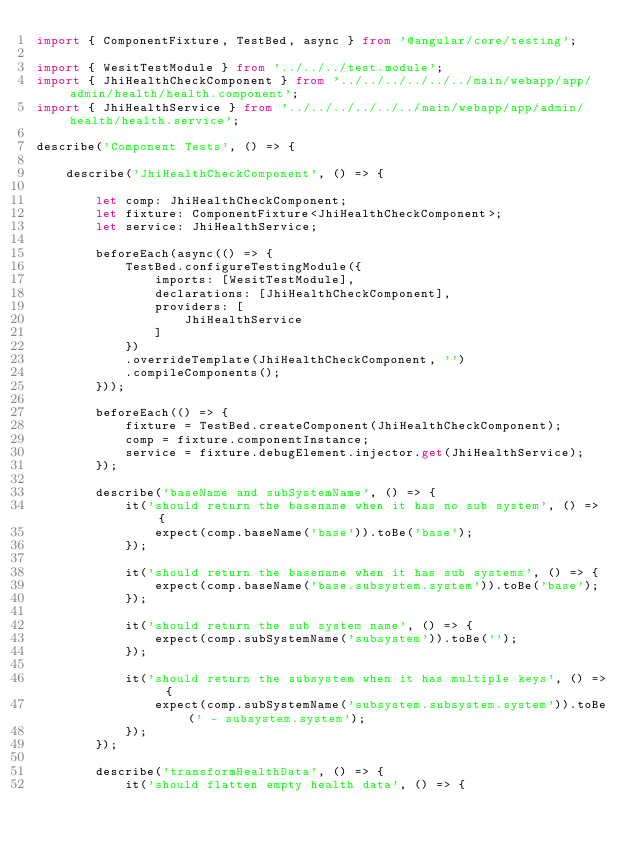Convert code to text. <code><loc_0><loc_0><loc_500><loc_500><_TypeScript_>import { ComponentFixture, TestBed, async } from '@angular/core/testing';

import { WesitTestModule } from '../../../test.module';
import { JhiHealthCheckComponent } from '../../../../../../main/webapp/app/admin/health/health.component';
import { JhiHealthService } from '../../../../../../main/webapp/app/admin/health/health.service';

describe('Component Tests', () => {

    describe('JhiHealthCheckComponent', () => {

        let comp: JhiHealthCheckComponent;
        let fixture: ComponentFixture<JhiHealthCheckComponent>;
        let service: JhiHealthService;

        beforeEach(async(() => {
            TestBed.configureTestingModule({
                imports: [WesitTestModule],
                declarations: [JhiHealthCheckComponent],
                providers: [
                    JhiHealthService
                ]
            })
            .overrideTemplate(JhiHealthCheckComponent, '')
            .compileComponents();
        }));

        beforeEach(() => {
            fixture = TestBed.createComponent(JhiHealthCheckComponent);
            comp = fixture.componentInstance;
            service = fixture.debugElement.injector.get(JhiHealthService);
        });

        describe('baseName and subSystemName', () => {
            it('should return the basename when it has no sub system', () => {
                expect(comp.baseName('base')).toBe('base');
            });

            it('should return the basename when it has sub systems', () => {
                expect(comp.baseName('base.subsystem.system')).toBe('base');
            });

            it('should return the sub system name', () => {
                expect(comp.subSystemName('subsystem')).toBe('');
            });

            it('should return the subsystem when it has multiple keys', () => {
                expect(comp.subSystemName('subsystem.subsystem.system')).toBe(' - subsystem.system');
            });
        });

        describe('transformHealthData', () => {
            it('should flatten empty health data', () => {</code> 